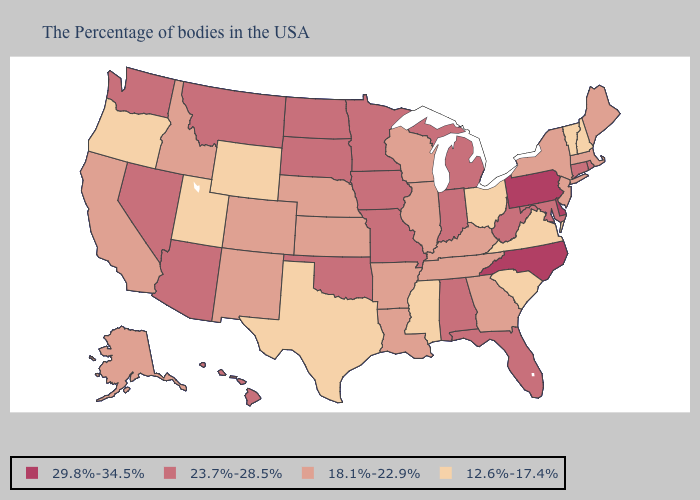Which states have the lowest value in the USA?
Be succinct. New Hampshire, Vermont, Virginia, South Carolina, Ohio, Mississippi, Texas, Wyoming, Utah, Oregon. Name the states that have a value in the range 29.8%-34.5%?
Keep it brief. Delaware, Pennsylvania, North Carolina. Does Kansas have a higher value than Oregon?
Concise answer only. Yes. Does Utah have the lowest value in the West?
Quick response, please. Yes. What is the highest value in states that border Texas?
Keep it brief. 23.7%-28.5%. Does Oregon have the highest value in the USA?
Answer briefly. No. Name the states that have a value in the range 23.7%-28.5%?
Answer briefly. Rhode Island, Connecticut, Maryland, West Virginia, Florida, Michigan, Indiana, Alabama, Missouri, Minnesota, Iowa, Oklahoma, South Dakota, North Dakota, Montana, Arizona, Nevada, Washington, Hawaii. Among the states that border Ohio , which have the lowest value?
Give a very brief answer. Kentucky. Is the legend a continuous bar?
Give a very brief answer. No. What is the highest value in states that border Washington?
Be succinct. 18.1%-22.9%. Name the states that have a value in the range 29.8%-34.5%?
Answer briefly. Delaware, Pennsylvania, North Carolina. Name the states that have a value in the range 12.6%-17.4%?
Write a very short answer. New Hampshire, Vermont, Virginia, South Carolina, Ohio, Mississippi, Texas, Wyoming, Utah, Oregon. Name the states that have a value in the range 29.8%-34.5%?
Be succinct. Delaware, Pennsylvania, North Carolina. What is the value of Delaware?
Short answer required. 29.8%-34.5%. Among the states that border Rhode Island , which have the highest value?
Keep it brief. Connecticut. 